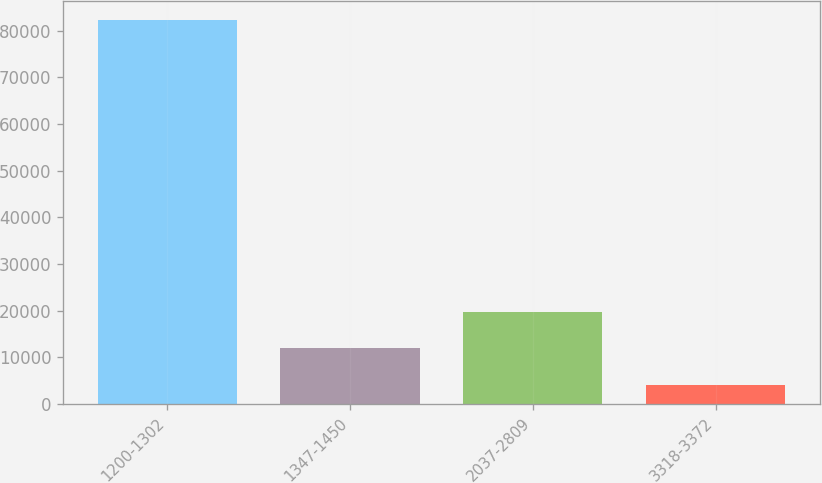<chart> <loc_0><loc_0><loc_500><loc_500><bar_chart><fcel>1200-1302<fcel>1347-1450<fcel>2037-2809<fcel>3318-3372<nl><fcel>82334<fcel>11907.2<fcel>19732.4<fcel>4082<nl></chart> 